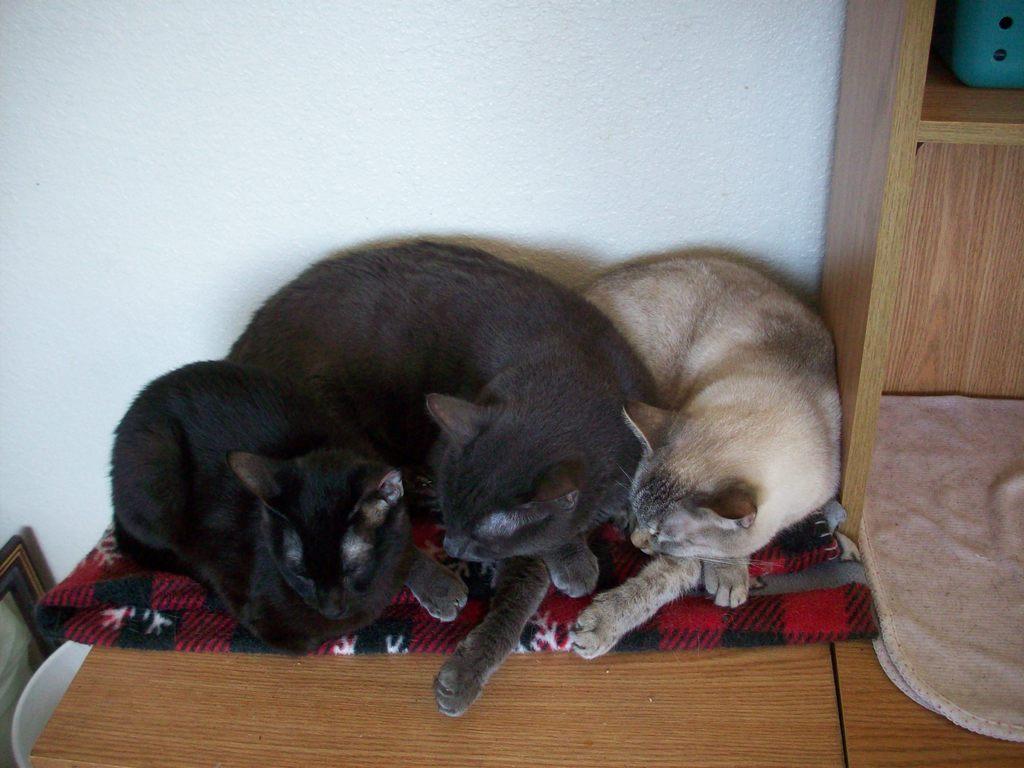Please provide a concise description of this image. In this picture we can see three cats laying on a cloth, there is a table here, on the right side there is a cupboard, we can see cloth here, in the background there is a wall. 